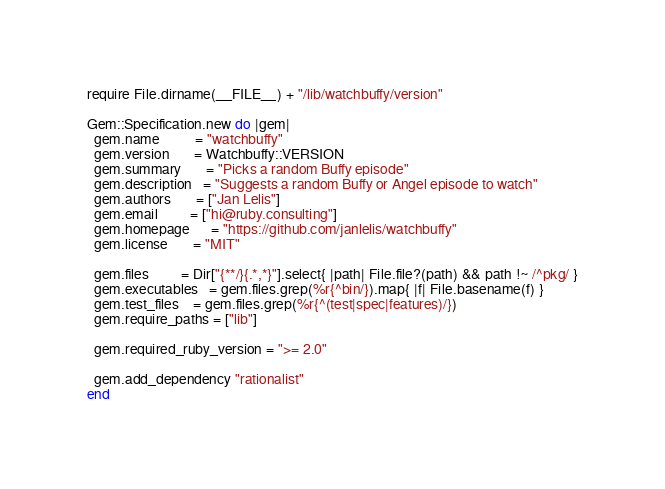Convert code to text. <code><loc_0><loc_0><loc_500><loc_500><_Ruby_>require File.dirname(__FILE__) + "/lib/watchbuffy/version"

Gem::Specification.new do |gem|
  gem.name          = "watchbuffy"
  gem.version       = Watchbuffy::VERSION
  gem.summary       = "Picks a random Buffy episode"
  gem.description   = "Suggests a random Buffy or Angel episode to watch"
  gem.authors       = ["Jan Lelis"]
  gem.email         = ["hi@ruby.consulting"]
  gem.homepage      = "https://github.com/janlelis/watchbuffy"
  gem.license       = "MIT"

  gem.files         = Dir["{**/}{.*,*}"].select{ |path| File.file?(path) && path !~ /^pkg/ }
  gem.executables   = gem.files.grep(%r{^bin/}).map{ |f| File.basename(f) }
  gem.test_files    = gem.files.grep(%r{^(test|spec|features)/})
  gem.require_paths = ["lib"]

  gem.required_ruby_version = ">= 2.0"

  gem.add_dependency "rationalist"
end
</code> 